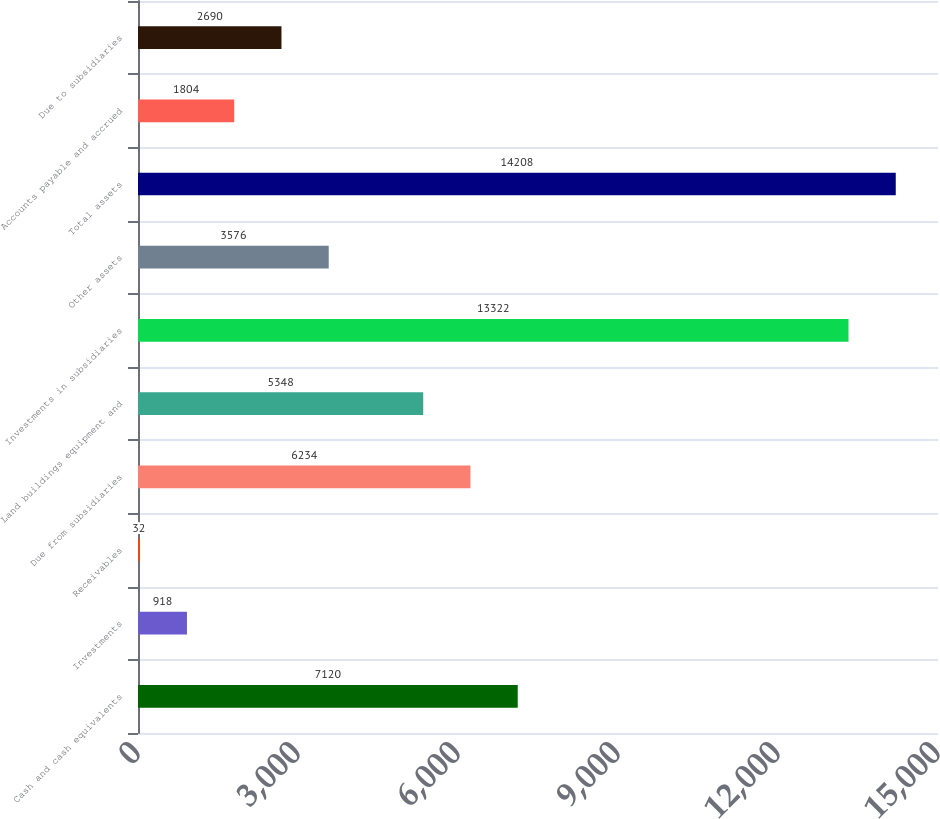Convert chart to OTSL. <chart><loc_0><loc_0><loc_500><loc_500><bar_chart><fcel>Cash and cash equivalents<fcel>Investments<fcel>Receivables<fcel>Due from subsidiaries<fcel>Land buildings equipment and<fcel>Investments in subsidiaries<fcel>Other assets<fcel>Total assets<fcel>Accounts payable and accrued<fcel>Due to subsidiaries<nl><fcel>7120<fcel>918<fcel>32<fcel>6234<fcel>5348<fcel>13322<fcel>3576<fcel>14208<fcel>1804<fcel>2690<nl></chart> 